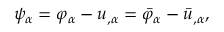Convert formula to latex. <formula><loc_0><loc_0><loc_500><loc_500>\psi _ { \alpha } = \varphi _ { \alpha } - u _ { , \alpha } = \bar { \varphi } _ { \alpha } - \bar { u } _ { , \alpha } ,</formula> 